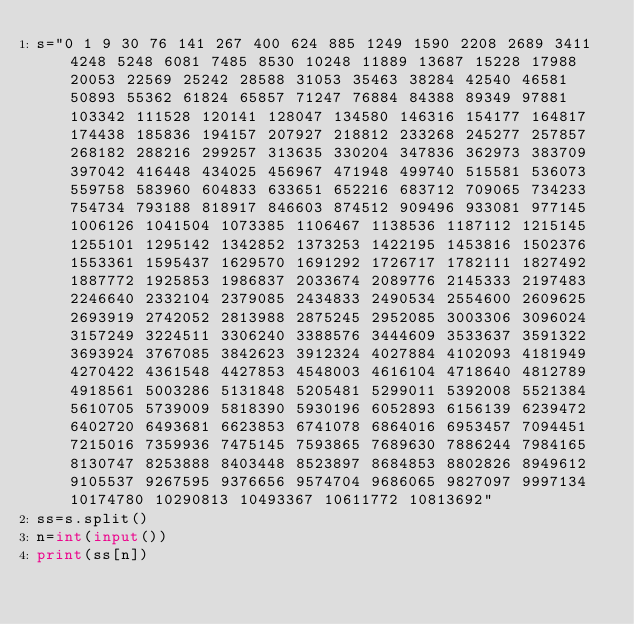<code> <loc_0><loc_0><loc_500><loc_500><_Python_>s="0 1 9 30 76 141 267 400 624 885 1249 1590 2208 2689 3411 4248 5248 6081 7485 8530 10248 11889 13687 15228 17988 20053 22569 25242 28588 31053 35463 38284 42540 46581 50893 55362 61824 65857 71247 76884 84388 89349 97881 103342 111528 120141 128047 134580 146316 154177 164817 174438 185836 194157 207927 218812 233268 245277 257857 268182 288216 299257 313635 330204 347836 362973 383709 397042 416448 434025 456967 471948 499740 515581 536073 559758 583960 604833 633651 652216 683712 709065 734233 754734 793188 818917 846603 874512 909496 933081 977145 1006126 1041504 1073385 1106467 1138536 1187112 1215145 1255101 1295142 1342852 1373253 1422195 1453816 1502376 1553361 1595437 1629570 1691292 1726717 1782111 1827492 1887772 1925853 1986837 2033674 2089776 2145333 2197483 2246640 2332104 2379085 2434833 2490534 2554600 2609625 2693919 2742052 2813988 2875245 2952085 3003306 3096024 3157249 3224511 3306240 3388576 3444609 3533637 3591322 3693924 3767085 3842623 3912324 4027884 4102093 4181949 4270422 4361548 4427853 4548003 4616104 4718640 4812789 4918561 5003286 5131848 5205481 5299011 5392008 5521384 5610705 5739009 5818390 5930196 6052893 6156139 6239472 6402720 6493681 6623853 6741078 6864016 6953457 7094451 7215016 7359936 7475145 7593865 7689630 7886244 7984165 8130747 8253888 8403448 8523897 8684853 8802826 8949612 9105537 9267595 9376656 9574704 9686065 9827097 9997134 10174780 10290813 10493367 10611772 10813692"
ss=s.split()
n=int(input())
print(ss[n])
</code> 